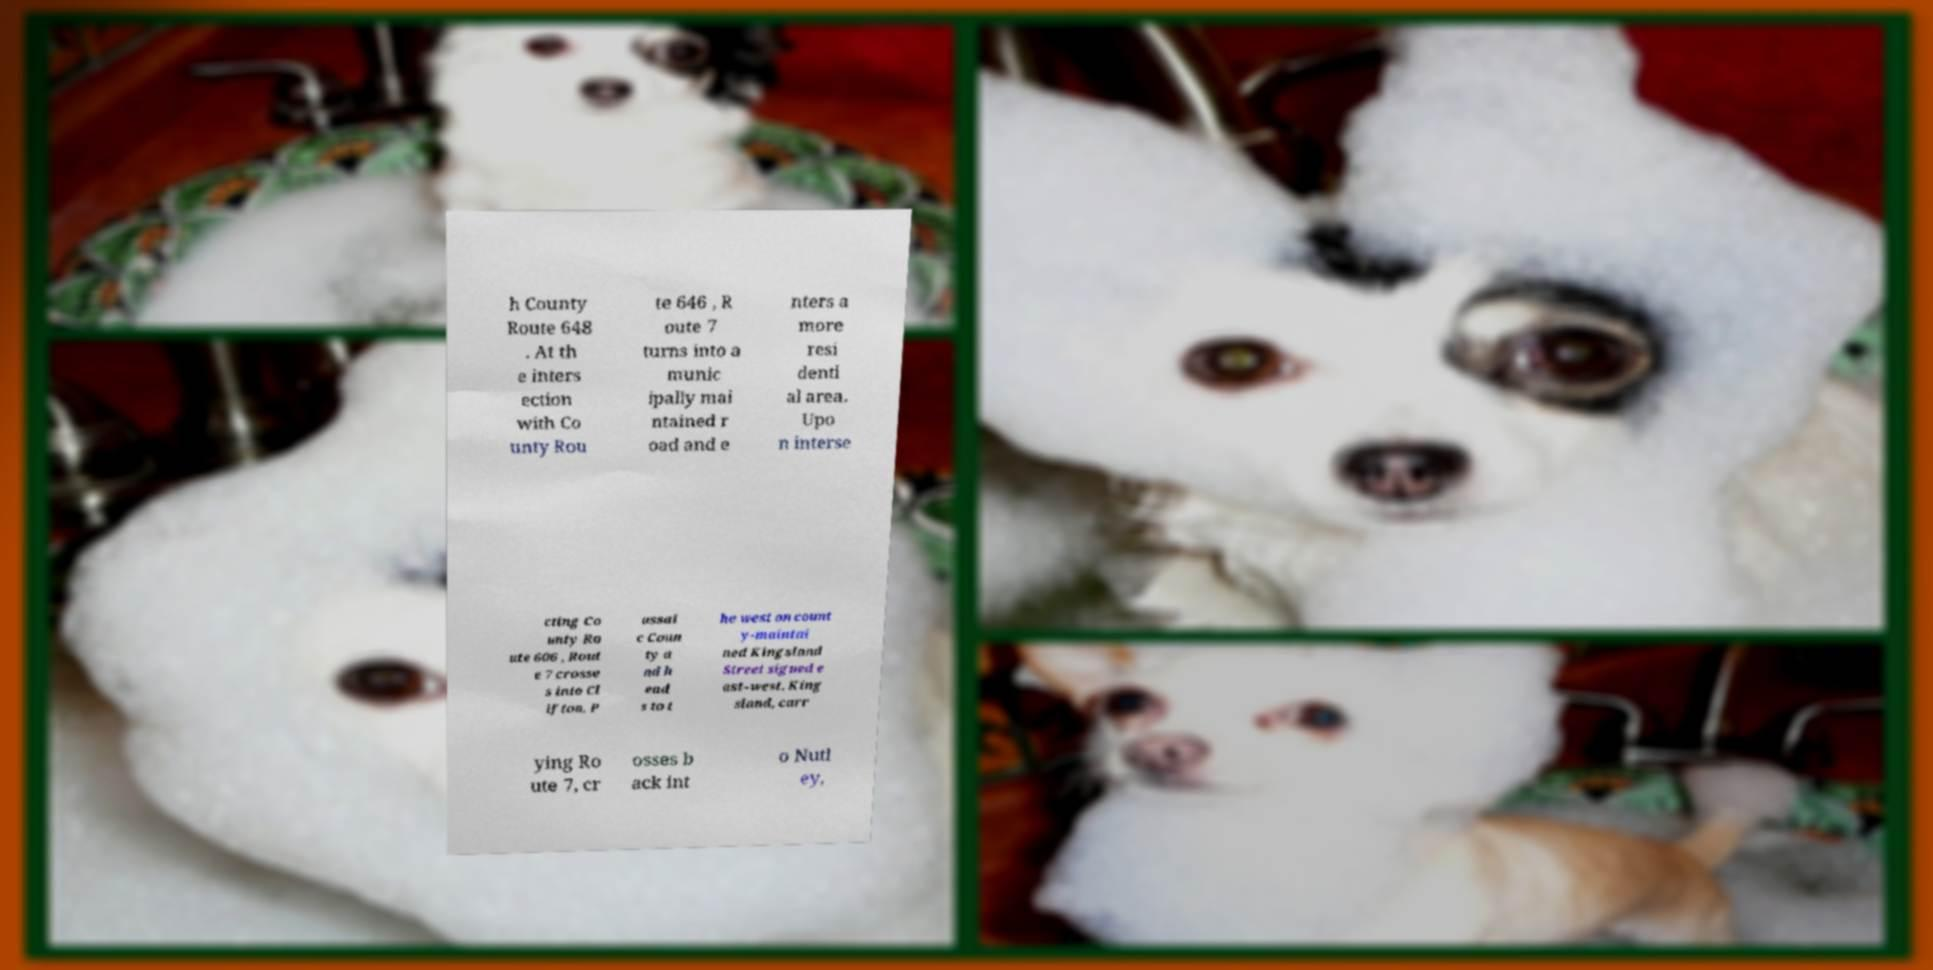Could you assist in decoding the text presented in this image and type it out clearly? h County Route 648 . At th e inters ection with Co unty Rou te 646 , R oute 7 turns into a munic ipally mai ntained r oad and e nters a more resi denti al area. Upo n interse cting Co unty Ro ute 606 , Rout e 7 crosse s into Cl ifton, P assai c Coun ty a nd h ead s to t he west on count y-maintai ned Kingsland Street signed e ast–west. King sland, carr ying Ro ute 7, cr osses b ack int o Nutl ey, 